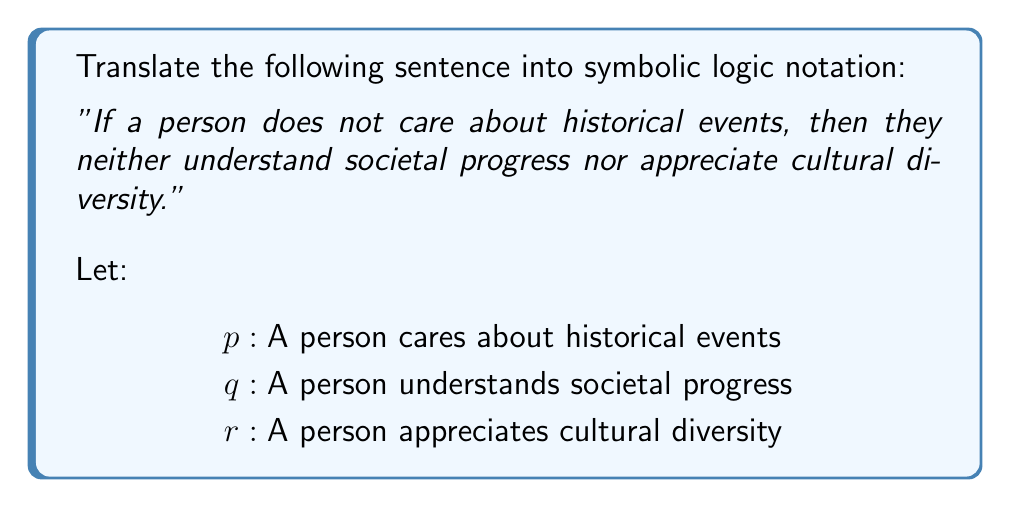Give your solution to this math problem. To translate this sentence into symbolic logic notation, we need to break it down into its logical components:

1. The sentence is in the form of an implication: "If ... then ..."

2. The antecedent (the "if" part) is "a person does not care about historical events." This is the negation of $p$, which we can write as $\neg p$.

3. The consequent (the "then" part) has two components connected by "nor":
   - "they do not understand societal progress"
   - "they do not appreciate cultural diversity"

4. "Nor" in logic is equivalent to "and not." So, we need to negate both $q$ and $r$ and connect them with a logical AND ($\land$).

5. The negation of $q$ is $\neg q$, and the negation of $r$ is $\neg r$.

6. Putting it all together, we have an implication ($\rightarrow$) where the antecedent is $\neg p$ and the consequent is $(\neg q \land \neg r)$.

Therefore, the symbolic logic notation for this sentence is:

$$\neg p \rightarrow (\neg q \land \neg r)$$

This can be read as "not $p$ implies (not $q$ and not $r$)."
Answer: $$\neg p \rightarrow (\neg q \land \neg r)$$ 